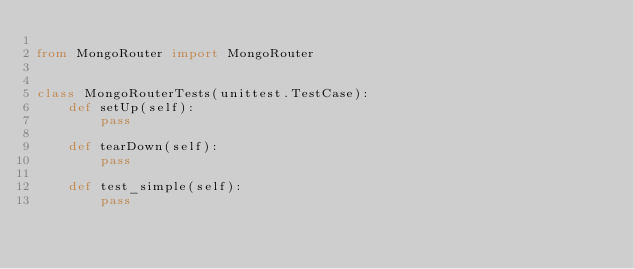Convert code to text. <code><loc_0><loc_0><loc_500><loc_500><_Python_>
from MongoRouter import MongoRouter


class MongoRouterTests(unittest.TestCase):
    def setUp(self):
        pass

    def tearDown(self):
        pass

    def test_simple(self):
        pass
</code> 